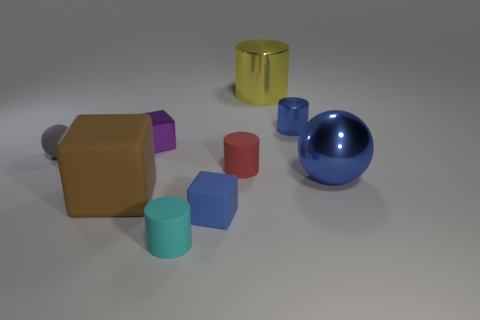There is a tiny gray matte object; is it the same shape as the tiny blue thing that is in front of the big brown rubber cube?
Make the answer very short. No. Is the size of the metallic object on the left side of the tiny cyan object the same as the metallic thing in front of the tiny gray sphere?
Your response must be concise. No. Are there any cyan matte objects on the right side of the tiny rubber cylinder that is behind the matte object that is in front of the small blue matte block?
Your answer should be very brief. No. Is the number of brown matte things behind the yellow cylinder less than the number of tiny blue shiny cylinders that are in front of the blue metallic sphere?
Provide a short and direct response. No. The yellow object that is made of the same material as the purple object is what shape?
Make the answer very short. Cylinder. What size is the metal cylinder behind the small metal thing that is on the right side of the metallic cylinder that is behind the tiny blue cylinder?
Make the answer very short. Large. Is the number of small purple objects greater than the number of yellow spheres?
Offer a terse response. Yes. Is the color of the cube behind the large matte cube the same as the large metallic ball in front of the tiny purple object?
Make the answer very short. No. Does the tiny block in front of the tiny gray sphere have the same material as the large thing that is behind the purple object?
Make the answer very short. No. What number of brown rubber objects are the same size as the purple shiny object?
Offer a very short reply. 0. 